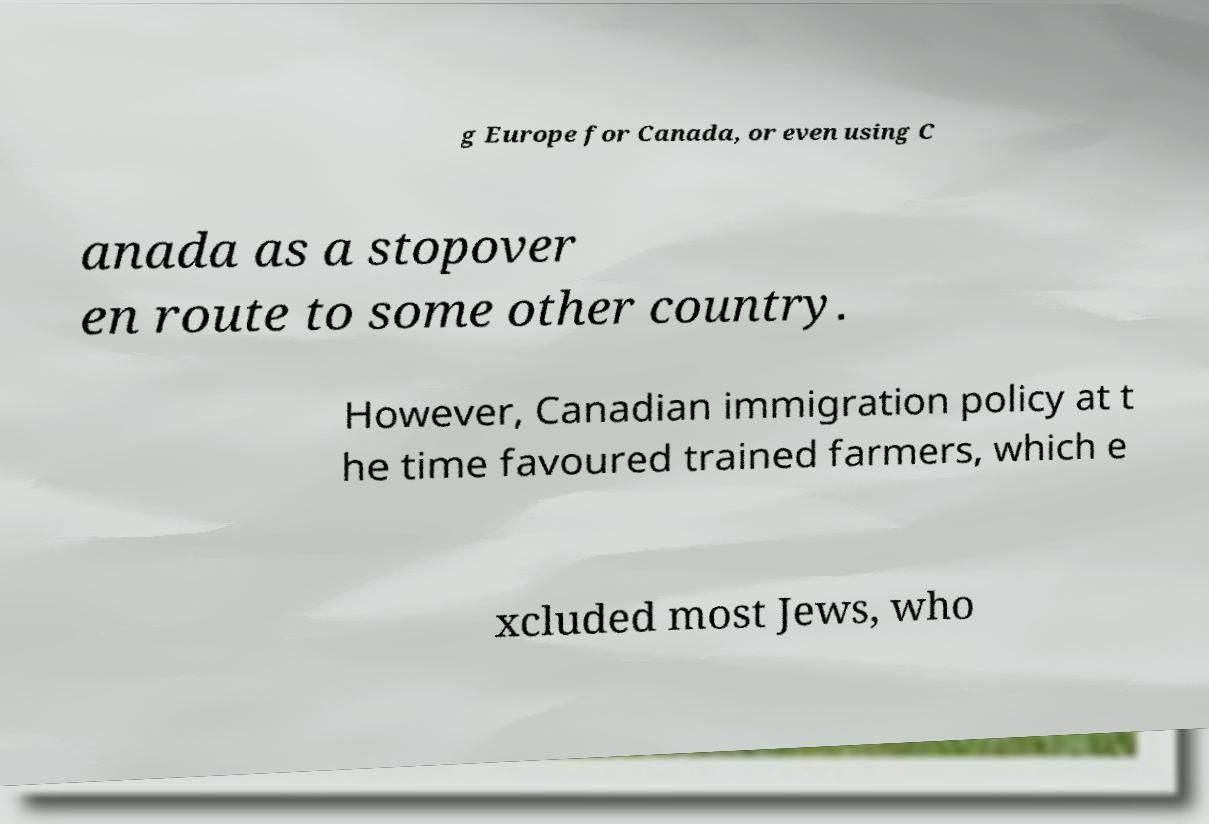Could you extract and type out the text from this image? g Europe for Canada, or even using C anada as a stopover en route to some other country. However, Canadian immigration policy at t he time favoured trained farmers, which e xcluded most Jews, who 